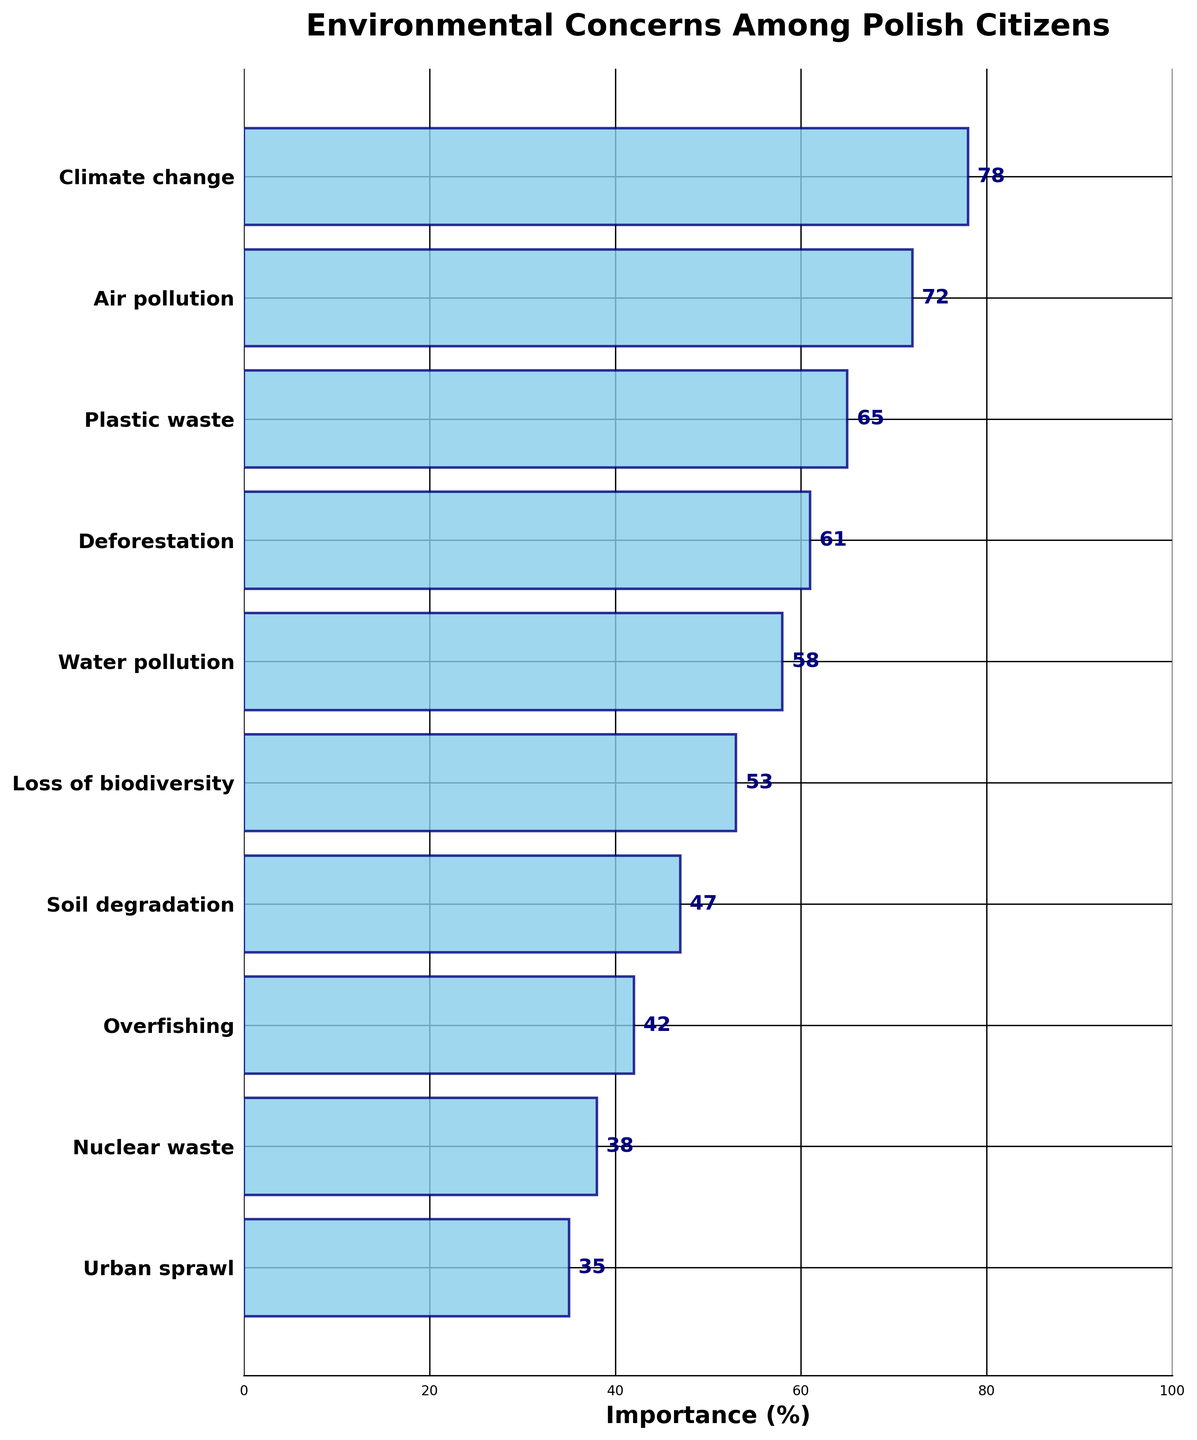What is the title of the plot? The title of the plot is displayed at the top center of the figure.
Answer: Environmental Concerns Among Polish Citizens What percentage of Polish citizens consider air pollution as an important environmental concern? The figure shows the percentage values next to each concern bar, and air pollution is marked with 72%.
Answer: 72% Which environmental concern is ranked highest in importance among Polish citizens? It’s the bar with the highest value, which is the first bar from the top marked with 78%.
Answer: Climate change How many environmental concerns have an importance percentage higher than 60%? By looking at the bars and their respective percentages, four concerns have values higher than 60%: Climate change (78%), Air pollution (72%), Plastic waste (65%), and Deforestation (61%).
Answer: 4 What is the combined importance percentage of water pollution and loss of biodiversity? Locate the percentages for water pollution (58%) and loss of biodiversity (53%), and sum them up: 58 + 53.
Answer: 111% Which concern has the lowest perceived importance? It’s the bar with the smallest value, which is at the bottom of the plot marked with 35%.
Answer: Urban sprawl Is plastic waste considered more important than soil degradation? Compare their percentages: Plastic waste (65%) is indeed higher than soil degradation (47%).
Answer: Yes How much more important is deforestation compared to urban sprawl? Subtract the percentage of urban sprawl (35%) from that of deforestation (61%): 61 – 35.
Answer: 26% What is the average importance percentage of all concerns listed in the plot? Sum all the percentages: 78 + 72 + 65 + 61 + 58 + 53 + 47 + 42 + 38 + 35 = 549, then divide by the number of concerns (10): 549 / 10.
Answer: 54.9% Which concerns have an importance percentage that is an even number? Identify the bars with even percentage values: Climate change (78%), Air pollution (72%), Plastic waste (65), Deforestation (61), Water pollution (58), Soil degradation (47), Nuclear waste (38), Urban sprawl (35). Only Climate change, Air pollution, Water pollution, and Nuclear waste have even numbers.
Answer: Climate change, Air pollution, Water pollution, Nuclear waste 